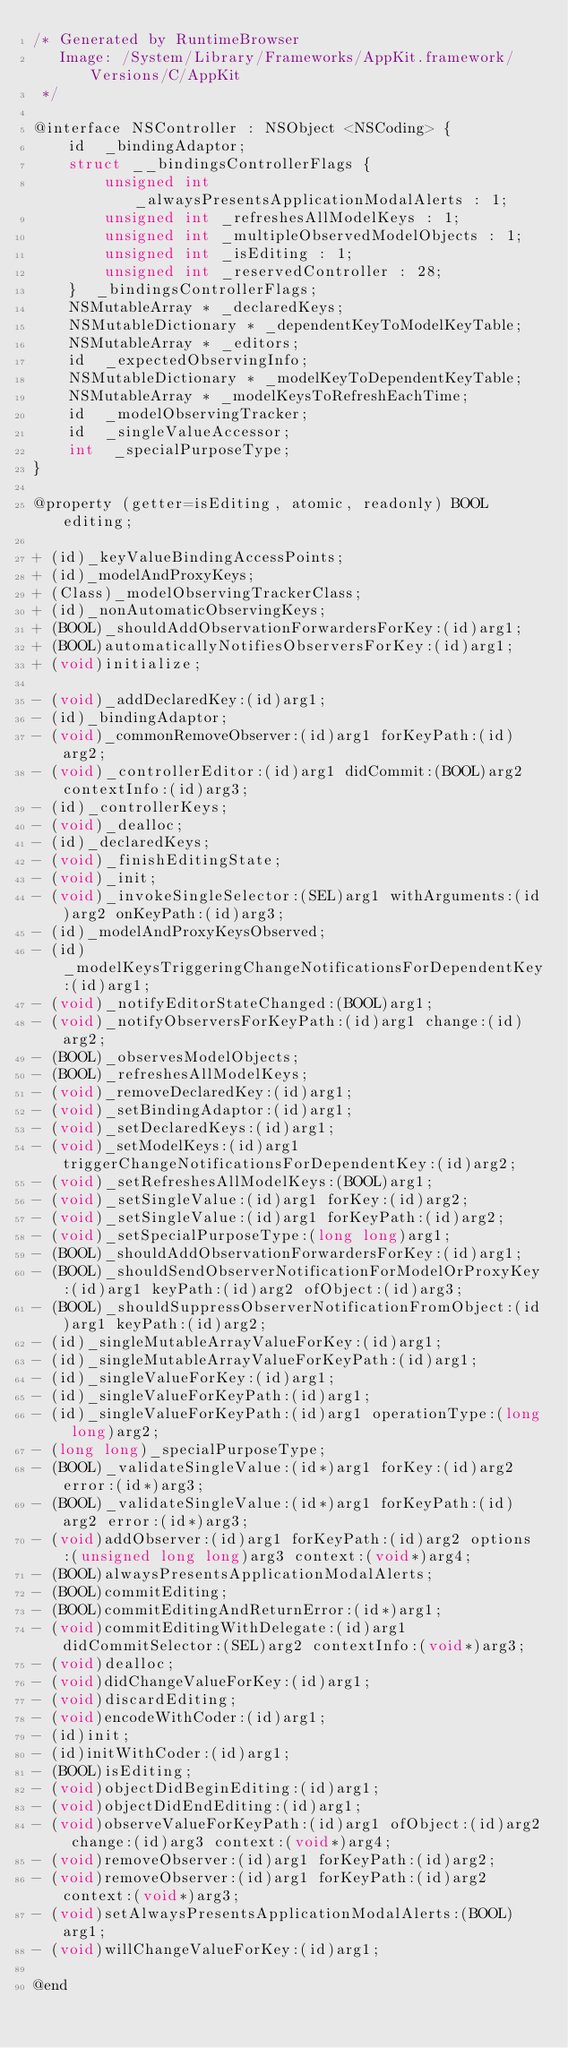Convert code to text. <code><loc_0><loc_0><loc_500><loc_500><_C_>/* Generated by RuntimeBrowser
   Image: /System/Library/Frameworks/AppKit.framework/Versions/C/AppKit
 */

@interface NSController : NSObject <NSCoding> {
    id  _bindingAdaptor;
    struct __bindingsControllerFlags { 
        unsigned int _alwaysPresentsApplicationModalAlerts : 1; 
        unsigned int _refreshesAllModelKeys : 1; 
        unsigned int _multipleObservedModelObjects : 1; 
        unsigned int _isEditing : 1; 
        unsigned int _reservedController : 28; 
    }  _bindingsControllerFlags;
    NSMutableArray * _declaredKeys;
    NSMutableDictionary * _dependentKeyToModelKeyTable;
    NSMutableArray * _editors;
    id  _expectedObservingInfo;
    NSMutableDictionary * _modelKeyToDependentKeyTable;
    NSMutableArray * _modelKeysToRefreshEachTime;
    id  _modelObservingTracker;
    id  _singleValueAccessor;
    int  _specialPurposeType;
}

@property (getter=isEditing, atomic, readonly) BOOL editing;

+ (id)_keyValueBindingAccessPoints;
+ (id)_modelAndProxyKeys;
+ (Class)_modelObservingTrackerClass;
+ (id)_nonAutomaticObservingKeys;
+ (BOOL)_shouldAddObservationForwardersForKey:(id)arg1;
+ (BOOL)automaticallyNotifiesObserversForKey:(id)arg1;
+ (void)initialize;

- (void)_addDeclaredKey:(id)arg1;
- (id)_bindingAdaptor;
- (void)_commonRemoveObserver:(id)arg1 forKeyPath:(id)arg2;
- (void)_controllerEditor:(id)arg1 didCommit:(BOOL)arg2 contextInfo:(id)arg3;
- (id)_controllerKeys;
- (void)_dealloc;
- (id)_declaredKeys;
- (void)_finishEditingState;
- (void)_init;
- (void)_invokeSingleSelector:(SEL)arg1 withArguments:(id)arg2 onKeyPath:(id)arg3;
- (id)_modelAndProxyKeysObserved;
- (id)_modelKeysTriggeringChangeNotificationsForDependentKey:(id)arg1;
- (void)_notifyEditorStateChanged:(BOOL)arg1;
- (void)_notifyObserversForKeyPath:(id)arg1 change:(id)arg2;
- (BOOL)_observesModelObjects;
- (BOOL)_refreshesAllModelKeys;
- (void)_removeDeclaredKey:(id)arg1;
- (void)_setBindingAdaptor:(id)arg1;
- (void)_setDeclaredKeys:(id)arg1;
- (void)_setModelKeys:(id)arg1 triggerChangeNotificationsForDependentKey:(id)arg2;
- (void)_setRefreshesAllModelKeys:(BOOL)arg1;
- (void)_setSingleValue:(id)arg1 forKey:(id)arg2;
- (void)_setSingleValue:(id)arg1 forKeyPath:(id)arg2;
- (void)_setSpecialPurposeType:(long long)arg1;
- (BOOL)_shouldAddObservationForwardersForKey:(id)arg1;
- (BOOL)_shouldSendObserverNotificationForModelOrProxyKey:(id)arg1 keyPath:(id)arg2 ofObject:(id)arg3;
- (BOOL)_shouldSuppressObserverNotificationFromObject:(id)arg1 keyPath:(id)arg2;
- (id)_singleMutableArrayValueForKey:(id)arg1;
- (id)_singleMutableArrayValueForKeyPath:(id)arg1;
- (id)_singleValueForKey:(id)arg1;
- (id)_singleValueForKeyPath:(id)arg1;
- (id)_singleValueForKeyPath:(id)arg1 operationType:(long long)arg2;
- (long long)_specialPurposeType;
- (BOOL)_validateSingleValue:(id*)arg1 forKey:(id)arg2 error:(id*)arg3;
- (BOOL)_validateSingleValue:(id*)arg1 forKeyPath:(id)arg2 error:(id*)arg3;
- (void)addObserver:(id)arg1 forKeyPath:(id)arg2 options:(unsigned long long)arg3 context:(void*)arg4;
- (BOOL)alwaysPresentsApplicationModalAlerts;
- (BOOL)commitEditing;
- (BOOL)commitEditingAndReturnError:(id*)arg1;
- (void)commitEditingWithDelegate:(id)arg1 didCommitSelector:(SEL)arg2 contextInfo:(void*)arg3;
- (void)dealloc;
- (void)didChangeValueForKey:(id)arg1;
- (void)discardEditing;
- (void)encodeWithCoder:(id)arg1;
- (id)init;
- (id)initWithCoder:(id)arg1;
- (BOOL)isEditing;
- (void)objectDidBeginEditing:(id)arg1;
- (void)objectDidEndEditing:(id)arg1;
- (void)observeValueForKeyPath:(id)arg1 ofObject:(id)arg2 change:(id)arg3 context:(void*)arg4;
- (void)removeObserver:(id)arg1 forKeyPath:(id)arg2;
- (void)removeObserver:(id)arg1 forKeyPath:(id)arg2 context:(void*)arg3;
- (void)setAlwaysPresentsApplicationModalAlerts:(BOOL)arg1;
- (void)willChangeValueForKey:(id)arg1;

@end
</code> 